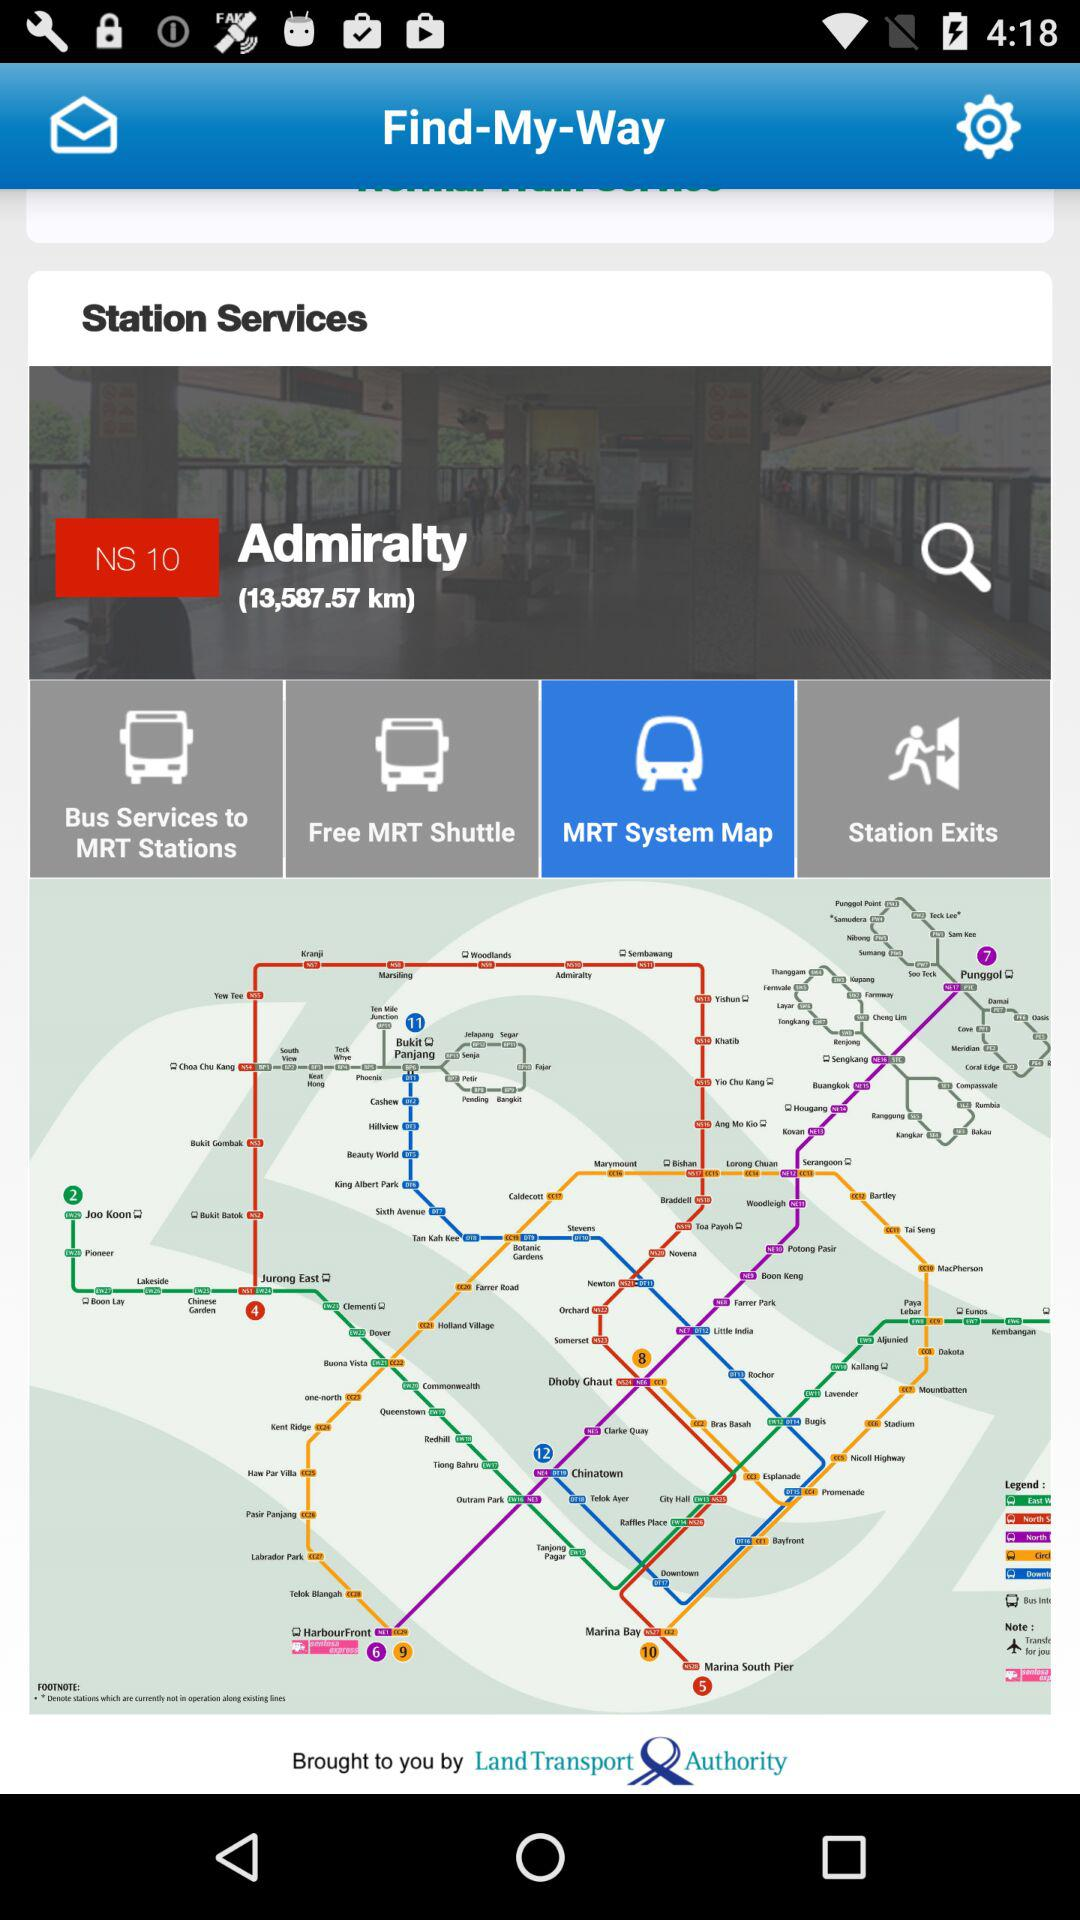Which option is selected in "Station Services"? The option that is selected in "Station Services" is "MRT System Map". 